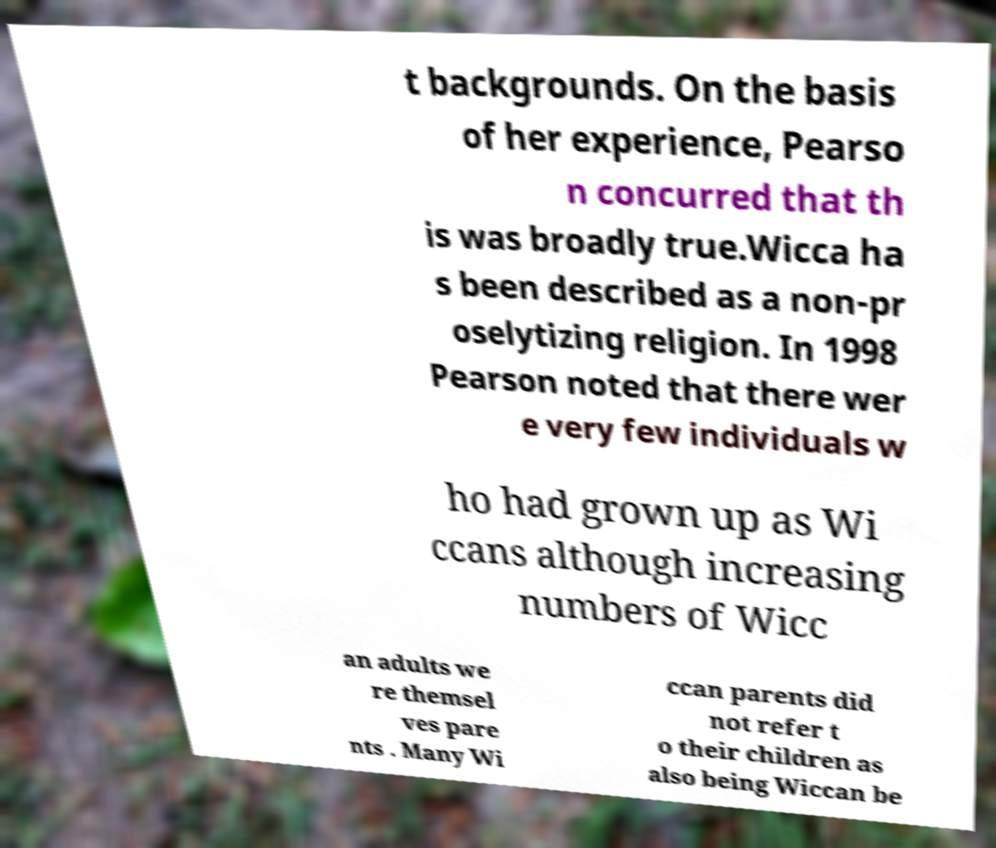Please read and relay the text visible in this image. What does it say? t backgrounds. On the basis of her experience, Pearso n concurred that th is was broadly true.Wicca ha s been described as a non-pr oselytizing religion. In 1998 Pearson noted that there wer e very few individuals w ho had grown up as Wi ccans although increasing numbers of Wicc an adults we re themsel ves pare nts . Many Wi ccan parents did not refer t o their children as also being Wiccan be 